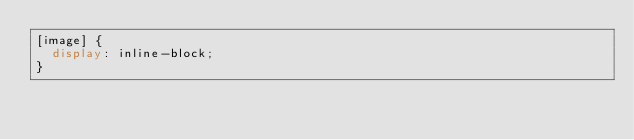Convert code to text. <code><loc_0><loc_0><loc_500><loc_500><_CSS_>[image] {
  display: inline-block;
}
</code> 